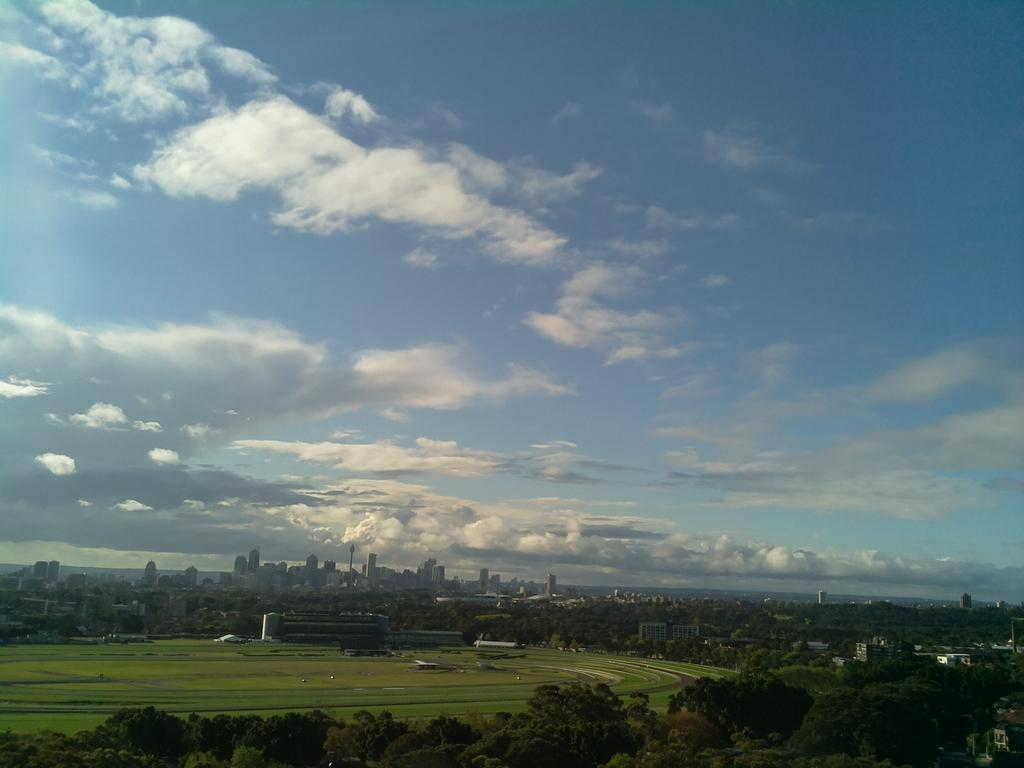What type of vegetation is in the foreground of the image? There are trees in the foreground of the image. What type of structures are visible in the background of the image? There are buildings in the background of the image. What is the surface that the trees and buildings are situated on? There is a ground in the middle of the image. How would you describe the weather based on the sky in the image? The sky is cloudy in the image. How many nuts are being used as currency in the image? There are no nuts present in the image, and therefore no such currency exchange can be observed. What type of frogs can be seen jumping on the buildings in the image? There are no frogs present in the image; it features trees in the foreground and buildings in the background. 